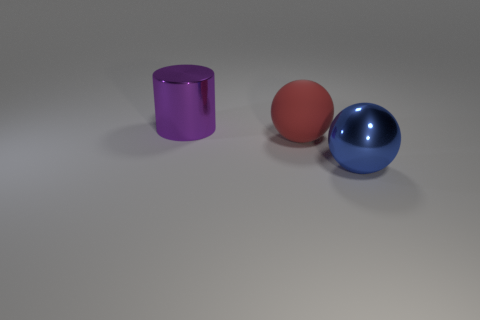There is a big metallic object to the right of the sphere that is left of the big shiny thing in front of the purple metallic object; what shape is it?
Offer a terse response. Sphere. What number of other objects are there of the same shape as the purple thing?
Make the answer very short. 0. The big ball on the left side of the shiny thing to the right of the purple shiny cylinder is made of what material?
Your answer should be compact. Rubber. Are there any other things that are the same size as the cylinder?
Keep it short and to the point. Yes. Do the big purple object and the ball that is in front of the red thing have the same material?
Provide a succinct answer. Yes. What is the object that is to the right of the big purple cylinder and left of the metallic ball made of?
Offer a very short reply. Rubber. What is the color of the shiny thing that is behind the sphere left of the blue object?
Your answer should be very brief. Purple. What is the material of the large sphere behind the metal ball?
Keep it short and to the point. Rubber. Are there fewer blue blocks than big blue spheres?
Your answer should be compact. Yes. Does the red matte thing have the same shape as the shiny thing that is left of the big blue object?
Make the answer very short. No. 